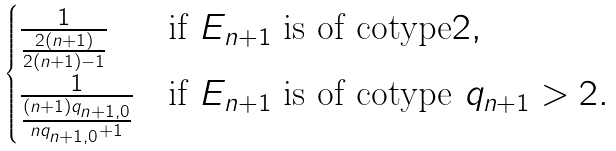<formula> <loc_0><loc_0><loc_500><loc_500>\begin{cases} \frac { 1 } { \frac { 2 ( n + 1 ) } { 2 ( n + 1 ) - 1 } } & \text {if $E_{n+1}$ is of cotype$2$} , \\ \frac { 1 } { \frac { ( n + 1 ) q _ { n + 1 , 0 } } { n q _ { n + 1 , 0 } + 1 } } & \text {if $E_{n+1}$ is of cotype $q_{n+1}>2$} . \end{cases}</formula> 